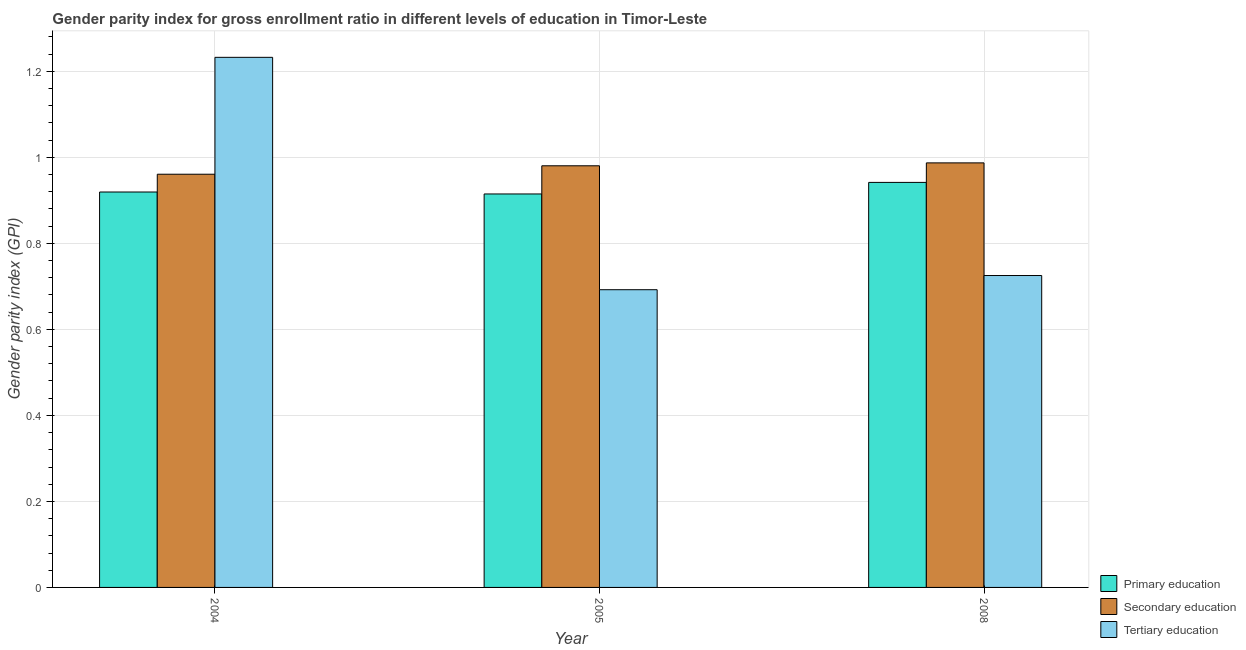How many different coloured bars are there?
Provide a succinct answer. 3. How many groups of bars are there?
Ensure brevity in your answer.  3. Are the number of bars on each tick of the X-axis equal?
Offer a terse response. Yes. What is the label of the 1st group of bars from the left?
Keep it short and to the point. 2004. What is the gender parity index in tertiary education in 2008?
Your response must be concise. 0.73. Across all years, what is the maximum gender parity index in primary education?
Keep it short and to the point. 0.94. Across all years, what is the minimum gender parity index in secondary education?
Ensure brevity in your answer.  0.96. In which year was the gender parity index in secondary education maximum?
Your response must be concise. 2008. What is the total gender parity index in secondary education in the graph?
Give a very brief answer. 2.93. What is the difference between the gender parity index in tertiary education in 2004 and that in 2008?
Keep it short and to the point. 0.51. What is the difference between the gender parity index in primary education in 2008 and the gender parity index in secondary education in 2004?
Ensure brevity in your answer.  0.02. What is the average gender parity index in tertiary education per year?
Ensure brevity in your answer.  0.88. In how many years, is the gender parity index in secondary education greater than 0.32?
Give a very brief answer. 3. What is the ratio of the gender parity index in tertiary education in 2004 to that in 2005?
Offer a terse response. 1.78. Is the difference between the gender parity index in tertiary education in 2005 and 2008 greater than the difference between the gender parity index in primary education in 2005 and 2008?
Keep it short and to the point. No. What is the difference between the highest and the second highest gender parity index in primary education?
Offer a very short reply. 0.02. What is the difference between the highest and the lowest gender parity index in secondary education?
Your answer should be compact. 0.03. Is the sum of the gender parity index in tertiary education in 2004 and 2008 greater than the maximum gender parity index in secondary education across all years?
Give a very brief answer. Yes. What does the 2nd bar from the left in 2008 represents?
Ensure brevity in your answer.  Secondary education. What does the 2nd bar from the right in 2005 represents?
Your answer should be compact. Secondary education. How many years are there in the graph?
Ensure brevity in your answer.  3. What is the difference between two consecutive major ticks on the Y-axis?
Ensure brevity in your answer.  0.2. Does the graph contain any zero values?
Keep it short and to the point. No. Does the graph contain grids?
Ensure brevity in your answer.  Yes. How are the legend labels stacked?
Provide a succinct answer. Vertical. What is the title of the graph?
Your answer should be very brief. Gender parity index for gross enrollment ratio in different levels of education in Timor-Leste. Does "Travel services" appear as one of the legend labels in the graph?
Your answer should be compact. No. What is the label or title of the Y-axis?
Offer a terse response. Gender parity index (GPI). What is the Gender parity index (GPI) of Primary education in 2004?
Offer a terse response. 0.92. What is the Gender parity index (GPI) of Secondary education in 2004?
Keep it short and to the point. 0.96. What is the Gender parity index (GPI) in Tertiary education in 2004?
Give a very brief answer. 1.23. What is the Gender parity index (GPI) in Primary education in 2005?
Your response must be concise. 0.91. What is the Gender parity index (GPI) in Secondary education in 2005?
Make the answer very short. 0.98. What is the Gender parity index (GPI) of Tertiary education in 2005?
Your response must be concise. 0.69. What is the Gender parity index (GPI) of Primary education in 2008?
Your response must be concise. 0.94. What is the Gender parity index (GPI) of Secondary education in 2008?
Provide a succinct answer. 0.99. What is the Gender parity index (GPI) of Tertiary education in 2008?
Offer a terse response. 0.73. Across all years, what is the maximum Gender parity index (GPI) in Primary education?
Ensure brevity in your answer.  0.94. Across all years, what is the maximum Gender parity index (GPI) in Secondary education?
Offer a terse response. 0.99. Across all years, what is the maximum Gender parity index (GPI) of Tertiary education?
Make the answer very short. 1.23. Across all years, what is the minimum Gender parity index (GPI) in Primary education?
Provide a succinct answer. 0.91. Across all years, what is the minimum Gender parity index (GPI) in Secondary education?
Your answer should be very brief. 0.96. Across all years, what is the minimum Gender parity index (GPI) in Tertiary education?
Offer a very short reply. 0.69. What is the total Gender parity index (GPI) in Primary education in the graph?
Offer a very short reply. 2.78. What is the total Gender parity index (GPI) in Secondary education in the graph?
Keep it short and to the point. 2.93. What is the total Gender parity index (GPI) in Tertiary education in the graph?
Make the answer very short. 2.65. What is the difference between the Gender parity index (GPI) in Primary education in 2004 and that in 2005?
Offer a terse response. 0. What is the difference between the Gender parity index (GPI) of Secondary education in 2004 and that in 2005?
Keep it short and to the point. -0.02. What is the difference between the Gender parity index (GPI) of Tertiary education in 2004 and that in 2005?
Offer a terse response. 0.54. What is the difference between the Gender parity index (GPI) of Primary education in 2004 and that in 2008?
Provide a succinct answer. -0.02. What is the difference between the Gender parity index (GPI) in Secondary education in 2004 and that in 2008?
Give a very brief answer. -0.03. What is the difference between the Gender parity index (GPI) of Tertiary education in 2004 and that in 2008?
Your answer should be very brief. 0.51. What is the difference between the Gender parity index (GPI) in Primary education in 2005 and that in 2008?
Offer a very short reply. -0.03. What is the difference between the Gender parity index (GPI) in Secondary education in 2005 and that in 2008?
Give a very brief answer. -0.01. What is the difference between the Gender parity index (GPI) in Tertiary education in 2005 and that in 2008?
Ensure brevity in your answer.  -0.03. What is the difference between the Gender parity index (GPI) of Primary education in 2004 and the Gender parity index (GPI) of Secondary education in 2005?
Ensure brevity in your answer.  -0.06. What is the difference between the Gender parity index (GPI) of Primary education in 2004 and the Gender parity index (GPI) of Tertiary education in 2005?
Make the answer very short. 0.23. What is the difference between the Gender parity index (GPI) of Secondary education in 2004 and the Gender parity index (GPI) of Tertiary education in 2005?
Ensure brevity in your answer.  0.27. What is the difference between the Gender parity index (GPI) of Primary education in 2004 and the Gender parity index (GPI) of Secondary education in 2008?
Your answer should be compact. -0.07. What is the difference between the Gender parity index (GPI) of Primary education in 2004 and the Gender parity index (GPI) of Tertiary education in 2008?
Offer a very short reply. 0.19. What is the difference between the Gender parity index (GPI) in Secondary education in 2004 and the Gender parity index (GPI) in Tertiary education in 2008?
Your response must be concise. 0.24. What is the difference between the Gender parity index (GPI) in Primary education in 2005 and the Gender parity index (GPI) in Secondary education in 2008?
Make the answer very short. -0.07. What is the difference between the Gender parity index (GPI) in Primary education in 2005 and the Gender parity index (GPI) in Tertiary education in 2008?
Your response must be concise. 0.19. What is the difference between the Gender parity index (GPI) in Secondary education in 2005 and the Gender parity index (GPI) in Tertiary education in 2008?
Provide a succinct answer. 0.26. What is the average Gender parity index (GPI) of Primary education per year?
Your answer should be compact. 0.93. What is the average Gender parity index (GPI) of Secondary education per year?
Your response must be concise. 0.98. What is the average Gender parity index (GPI) in Tertiary education per year?
Provide a short and direct response. 0.88. In the year 2004, what is the difference between the Gender parity index (GPI) of Primary education and Gender parity index (GPI) of Secondary education?
Your answer should be compact. -0.04. In the year 2004, what is the difference between the Gender parity index (GPI) in Primary education and Gender parity index (GPI) in Tertiary education?
Make the answer very short. -0.31. In the year 2004, what is the difference between the Gender parity index (GPI) of Secondary education and Gender parity index (GPI) of Tertiary education?
Make the answer very short. -0.27. In the year 2005, what is the difference between the Gender parity index (GPI) of Primary education and Gender parity index (GPI) of Secondary education?
Offer a terse response. -0.07. In the year 2005, what is the difference between the Gender parity index (GPI) in Primary education and Gender parity index (GPI) in Tertiary education?
Give a very brief answer. 0.22. In the year 2005, what is the difference between the Gender parity index (GPI) in Secondary education and Gender parity index (GPI) in Tertiary education?
Keep it short and to the point. 0.29. In the year 2008, what is the difference between the Gender parity index (GPI) in Primary education and Gender parity index (GPI) in Secondary education?
Keep it short and to the point. -0.05. In the year 2008, what is the difference between the Gender parity index (GPI) of Primary education and Gender parity index (GPI) of Tertiary education?
Ensure brevity in your answer.  0.22. In the year 2008, what is the difference between the Gender parity index (GPI) of Secondary education and Gender parity index (GPI) of Tertiary education?
Ensure brevity in your answer.  0.26. What is the ratio of the Gender parity index (GPI) of Primary education in 2004 to that in 2005?
Ensure brevity in your answer.  1. What is the ratio of the Gender parity index (GPI) of Tertiary education in 2004 to that in 2005?
Keep it short and to the point. 1.78. What is the ratio of the Gender parity index (GPI) in Primary education in 2004 to that in 2008?
Keep it short and to the point. 0.98. What is the ratio of the Gender parity index (GPI) of Secondary education in 2004 to that in 2008?
Offer a very short reply. 0.97. What is the ratio of the Gender parity index (GPI) of Tertiary education in 2004 to that in 2008?
Give a very brief answer. 1.7. What is the ratio of the Gender parity index (GPI) in Primary education in 2005 to that in 2008?
Make the answer very short. 0.97. What is the ratio of the Gender parity index (GPI) in Tertiary education in 2005 to that in 2008?
Your response must be concise. 0.95. What is the difference between the highest and the second highest Gender parity index (GPI) of Primary education?
Make the answer very short. 0.02. What is the difference between the highest and the second highest Gender parity index (GPI) of Secondary education?
Ensure brevity in your answer.  0.01. What is the difference between the highest and the second highest Gender parity index (GPI) in Tertiary education?
Give a very brief answer. 0.51. What is the difference between the highest and the lowest Gender parity index (GPI) in Primary education?
Your answer should be compact. 0.03. What is the difference between the highest and the lowest Gender parity index (GPI) of Secondary education?
Give a very brief answer. 0.03. What is the difference between the highest and the lowest Gender parity index (GPI) of Tertiary education?
Offer a very short reply. 0.54. 